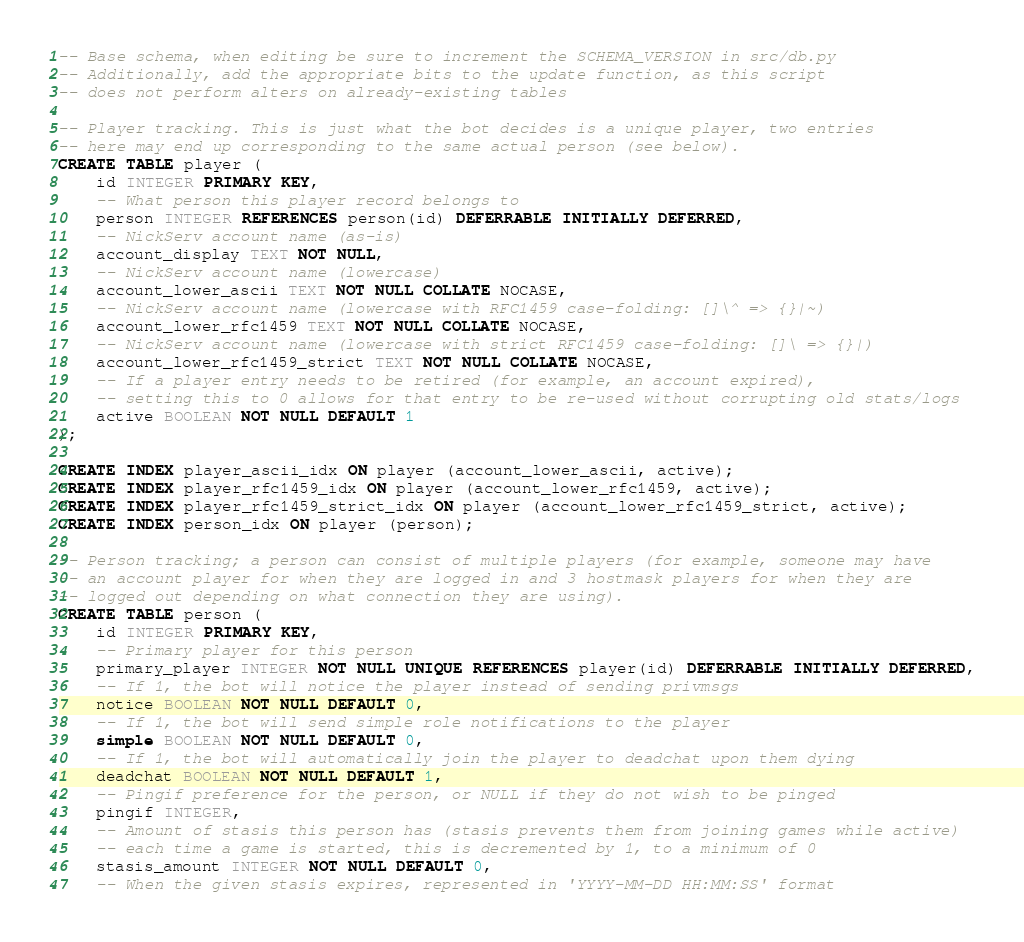Convert code to text. <code><loc_0><loc_0><loc_500><loc_500><_SQL_>-- Base schema, when editing be sure to increment the SCHEMA_VERSION in src/db.py
-- Additionally, add the appropriate bits to the update function, as this script
-- does not perform alters on already-existing tables

-- Player tracking. This is just what the bot decides is a unique player, two entries
-- here may end up corresponding to the same actual person (see below).
CREATE TABLE player (
    id INTEGER PRIMARY KEY,
    -- What person this player record belongs to
    person INTEGER REFERENCES person(id) DEFERRABLE INITIALLY DEFERRED,
    -- NickServ account name (as-is)
    account_display TEXT NOT NULL,
    -- NickServ account name (lowercase)
    account_lower_ascii TEXT NOT NULL COLLATE NOCASE,
    -- NickServ account name (lowercase with RFC1459 case-folding: []\^ => {}|~)
    account_lower_rfc1459 TEXT NOT NULL COLLATE NOCASE,
    -- NickServ account name (lowercase with strict RFC1459 case-folding: []\ => {}|)
    account_lower_rfc1459_strict TEXT NOT NULL COLLATE NOCASE,
    -- If a player entry needs to be retired (for example, an account expired),
    -- setting this to 0 allows for that entry to be re-used without corrupting old stats/logs
    active BOOLEAN NOT NULL DEFAULT 1
);

CREATE INDEX player_ascii_idx ON player (account_lower_ascii, active);
CREATE INDEX player_rfc1459_idx ON player (account_lower_rfc1459, active);
CREATE INDEX player_rfc1459_strict_idx ON player (account_lower_rfc1459_strict, active);
CREATE INDEX person_idx ON player (person);

-- Person tracking; a person can consist of multiple players (for example, someone may have
-- an account player for when they are logged in and 3 hostmask players for when they are
-- logged out depending on what connection they are using).
CREATE TABLE person (
    id INTEGER PRIMARY KEY,
    -- Primary player for this person
    primary_player INTEGER NOT NULL UNIQUE REFERENCES player(id) DEFERRABLE INITIALLY DEFERRED,
    -- If 1, the bot will notice the player instead of sending privmsgs
    notice BOOLEAN NOT NULL DEFAULT 0,
    -- If 1, the bot will send simple role notifications to the player
    simple BOOLEAN NOT NULL DEFAULT 0,
    -- If 1, the bot will automatically join the player to deadchat upon them dying
    deadchat BOOLEAN NOT NULL DEFAULT 1,
    -- Pingif preference for the person, or NULL if they do not wish to be pinged
    pingif INTEGER,
    -- Amount of stasis this person has (stasis prevents them from joining games while active)
    -- each time a game is started, this is decremented by 1, to a minimum of 0
    stasis_amount INTEGER NOT NULL DEFAULT 0,
    -- When the given stasis expires, represented in 'YYYY-MM-DD HH:MM:SS' format</code> 